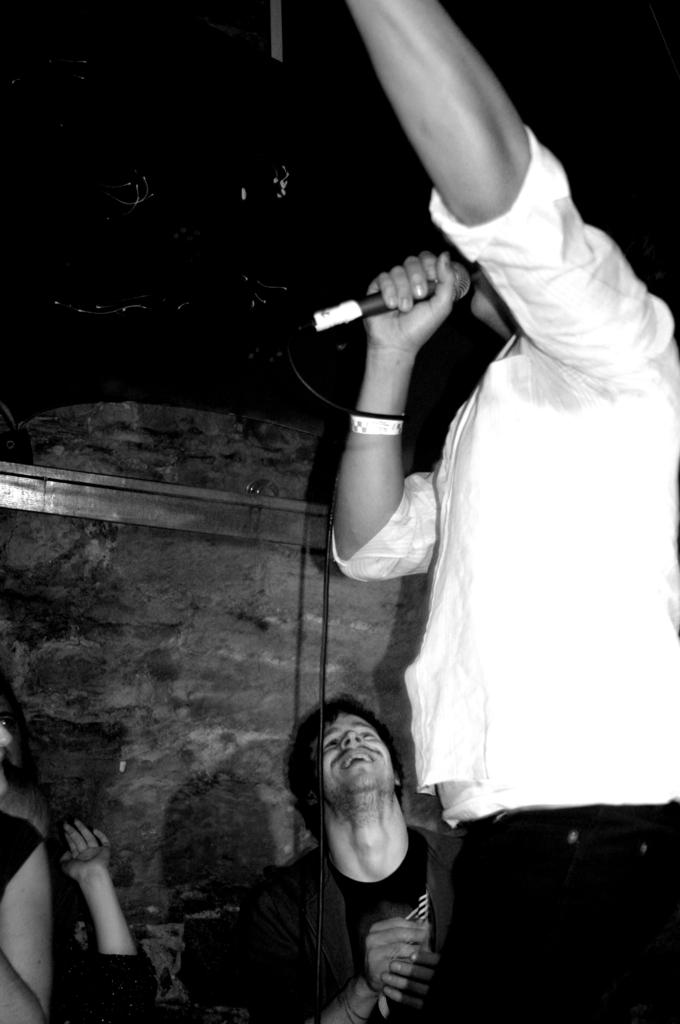What is present in the image that serves as a background? There is a wall in the image. Are there any people in the image? Yes, there are people in the image. Can you describe the position of the man in the image? The man is standing on the right side of the image. What is the man wearing in the image? The man is wearing a white jacket. How would you describe the lighting in the image? The image is slightly dark. How many boys and girls are present in the image? The provided facts do not mention the presence of boys or girls in the image. 